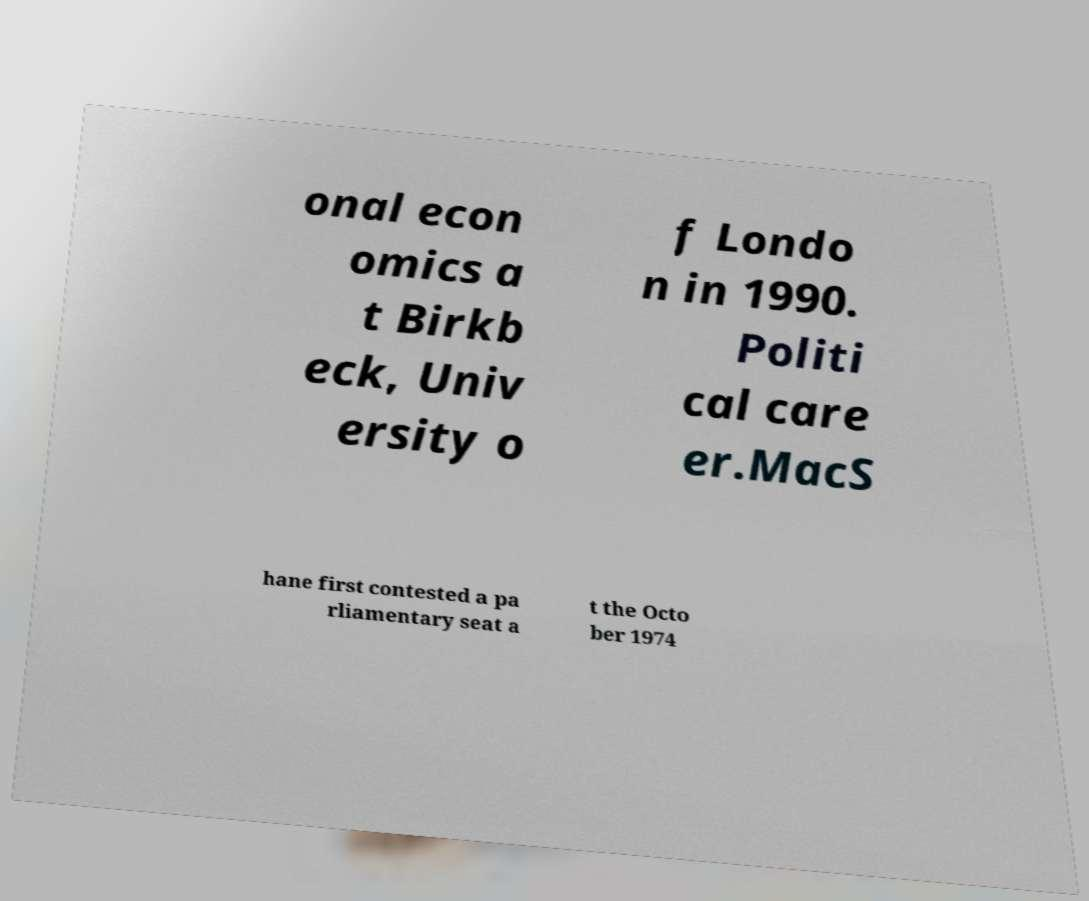Can you accurately transcribe the text from the provided image for me? onal econ omics a t Birkb eck, Univ ersity o f Londo n in 1990. Politi cal care er.MacS hane first contested a pa rliamentary seat a t the Octo ber 1974 